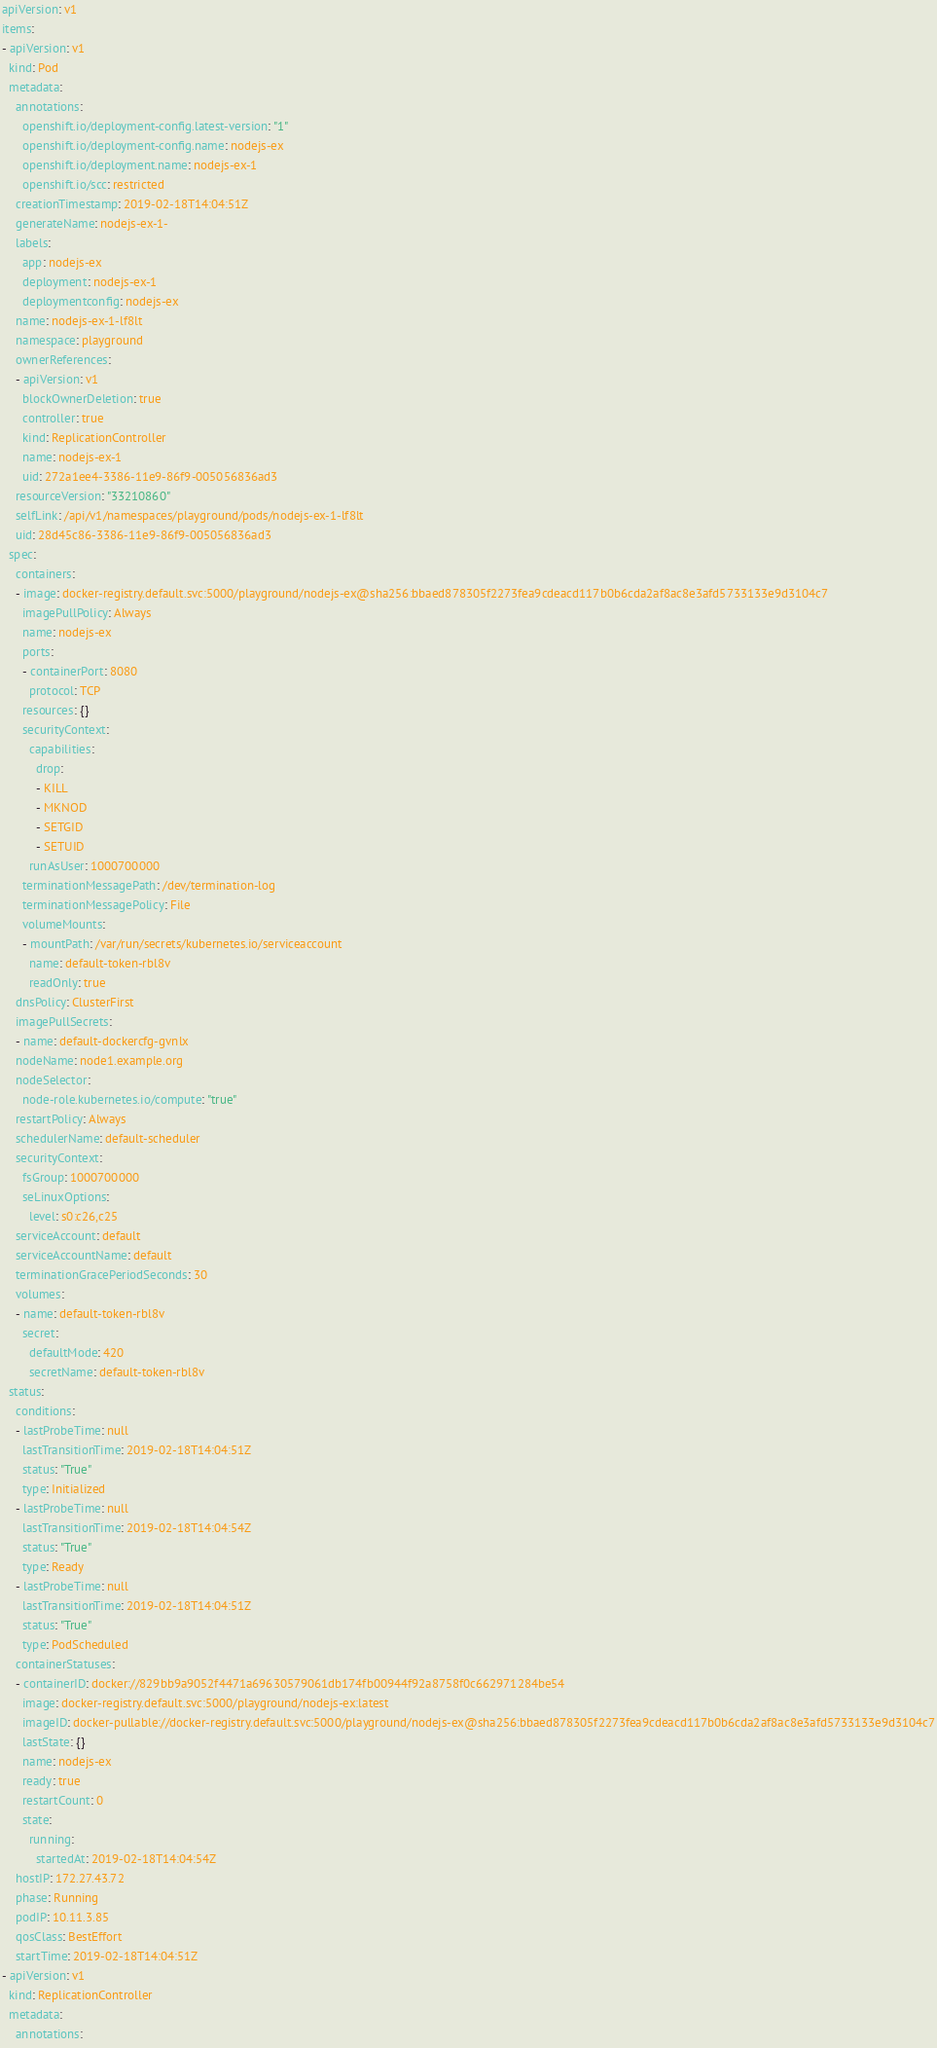<code> <loc_0><loc_0><loc_500><loc_500><_YAML_>apiVersion: v1
items:
- apiVersion: v1
  kind: Pod
  metadata:
    annotations:
      openshift.io/deployment-config.latest-version: "1"
      openshift.io/deployment-config.name: nodejs-ex
      openshift.io/deployment.name: nodejs-ex-1
      openshift.io/scc: restricted
    creationTimestamp: 2019-02-18T14:04:51Z
    generateName: nodejs-ex-1-
    labels:
      app: nodejs-ex
      deployment: nodejs-ex-1
      deploymentconfig: nodejs-ex
    name: nodejs-ex-1-lf8lt
    namespace: playground
    ownerReferences:
    - apiVersion: v1
      blockOwnerDeletion: true
      controller: true
      kind: ReplicationController
      name: nodejs-ex-1
      uid: 272a1ee4-3386-11e9-86f9-005056836ad3
    resourceVersion: "33210860"
    selfLink: /api/v1/namespaces/playground/pods/nodejs-ex-1-lf8lt
    uid: 28d45c86-3386-11e9-86f9-005056836ad3
  spec:
    containers:
    - image: docker-registry.default.svc:5000/playground/nodejs-ex@sha256:bbaed878305f2273fea9cdeacd117b0b6cda2af8ac8e3afd5733133e9d3104c7
      imagePullPolicy: Always
      name: nodejs-ex
      ports:
      - containerPort: 8080
        protocol: TCP
      resources: {}
      securityContext:
        capabilities:
          drop:
          - KILL
          - MKNOD
          - SETGID
          - SETUID
        runAsUser: 1000700000
      terminationMessagePath: /dev/termination-log
      terminationMessagePolicy: File
      volumeMounts:
      - mountPath: /var/run/secrets/kubernetes.io/serviceaccount
        name: default-token-rbl8v
        readOnly: true
    dnsPolicy: ClusterFirst
    imagePullSecrets:
    - name: default-dockercfg-gvnlx
    nodeName: node1.example.org
    nodeSelector:
      node-role.kubernetes.io/compute: "true"
    restartPolicy: Always
    schedulerName: default-scheduler
    securityContext:
      fsGroup: 1000700000
      seLinuxOptions:
        level: s0:c26,c25
    serviceAccount: default
    serviceAccountName: default
    terminationGracePeriodSeconds: 30
    volumes:
    - name: default-token-rbl8v
      secret:
        defaultMode: 420
        secretName: default-token-rbl8v
  status:
    conditions:
    - lastProbeTime: null
      lastTransitionTime: 2019-02-18T14:04:51Z
      status: "True"
      type: Initialized
    - lastProbeTime: null
      lastTransitionTime: 2019-02-18T14:04:54Z
      status: "True"
      type: Ready
    - lastProbeTime: null
      lastTransitionTime: 2019-02-18T14:04:51Z
      status: "True"
      type: PodScheduled
    containerStatuses:
    - containerID: docker://829bb9a9052f4471a69630579061db174fb00944f92a8758f0c662971284be54
      image: docker-registry.default.svc:5000/playground/nodejs-ex:latest
      imageID: docker-pullable://docker-registry.default.svc:5000/playground/nodejs-ex@sha256:bbaed878305f2273fea9cdeacd117b0b6cda2af8ac8e3afd5733133e9d3104c7
      lastState: {}
      name: nodejs-ex
      ready: true
      restartCount: 0
      state:
        running:
          startedAt: 2019-02-18T14:04:54Z
    hostIP: 172.27.43.72
    phase: Running
    podIP: 10.11.3.85
    qosClass: BestEffort
    startTime: 2019-02-18T14:04:51Z
- apiVersion: v1
  kind: ReplicationController
  metadata:
    annotations:</code> 